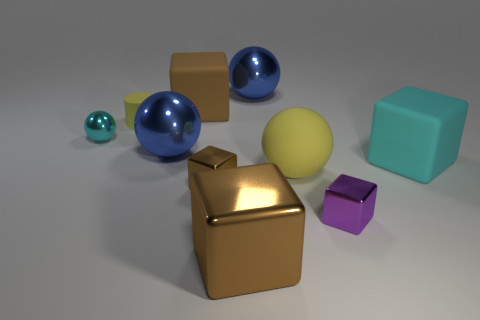The other shiny cube that is the same color as the large metal cube is what size?
Make the answer very short. Small. There is a tiny object that is the same color as the big shiny block; what is it made of?
Your response must be concise. Metal. What size is the brown matte cube?
Make the answer very short. Large. How many other objects are the same color as the rubber cylinder?
Offer a very short reply. 1. There is a large brown object that is behind the tiny purple block; is it the same shape as the cyan matte object?
Your answer should be compact. Yes. What is the color of the big metallic object that is the same shape as the brown matte object?
Provide a succinct answer. Brown. There is a purple object that is the same shape as the big cyan object; what size is it?
Keep it short and to the point. Small. What is the cube that is in front of the matte sphere and to the right of the big yellow rubber sphere made of?
Your response must be concise. Metal. Is the color of the small block on the left side of the yellow rubber sphere the same as the large shiny cube?
Offer a terse response. Yes. Do the small matte cylinder and the big matte ball to the left of the purple thing have the same color?
Offer a terse response. Yes. 